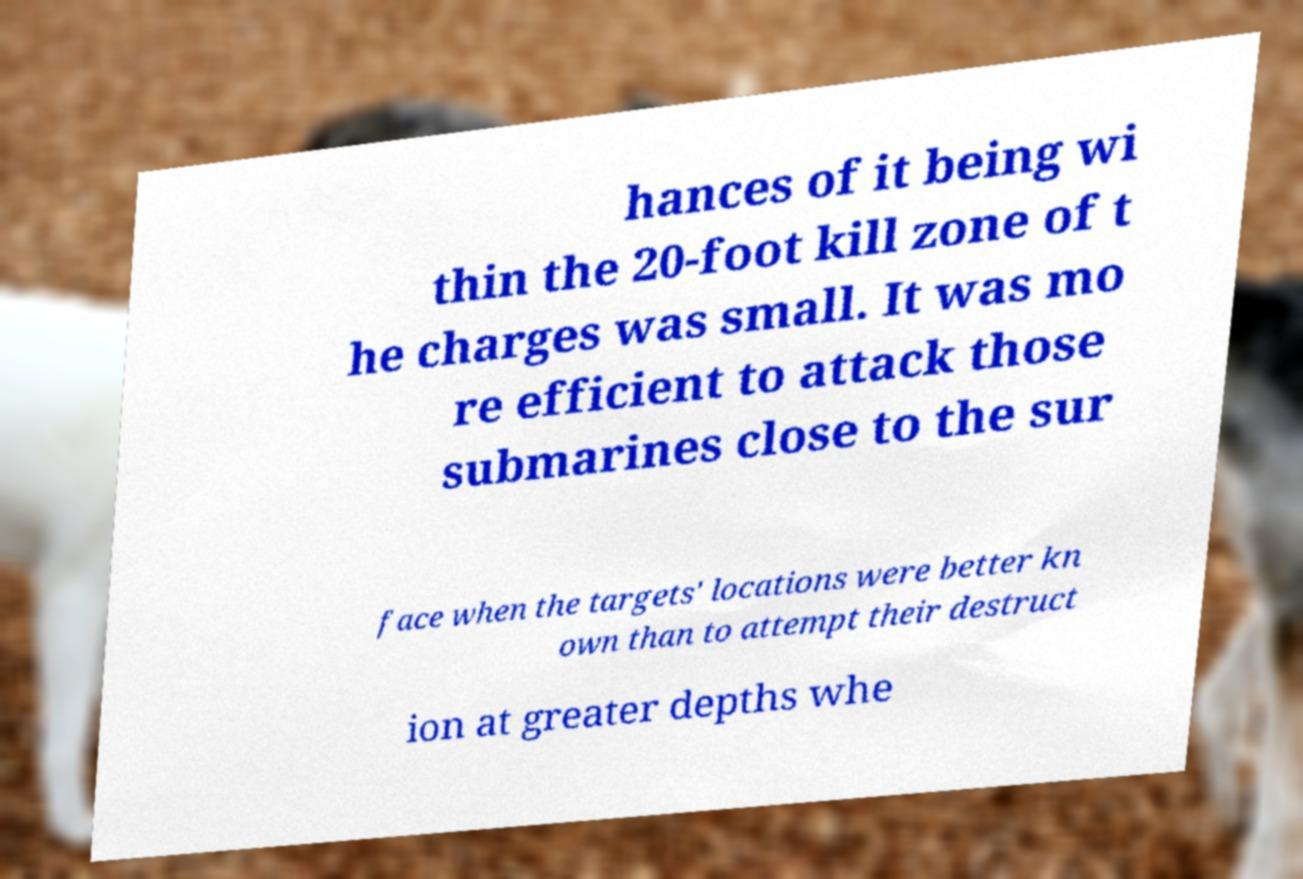I need the written content from this picture converted into text. Can you do that? hances of it being wi thin the 20-foot kill zone of t he charges was small. It was mo re efficient to attack those submarines close to the sur face when the targets' locations were better kn own than to attempt their destruct ion at greater depths whe 